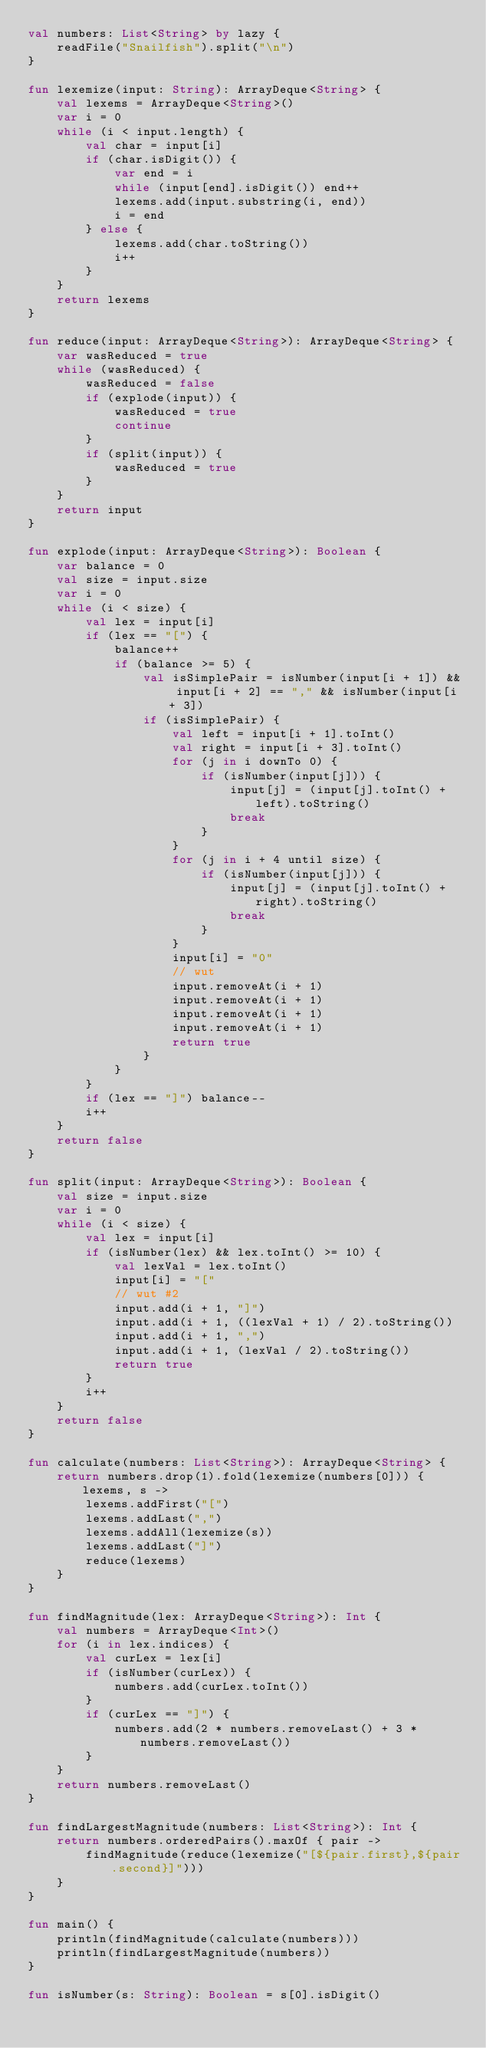Convert code to text. <code><loc_0><loc_0><loc_500><loc_500><_Kotlin_>val numbers: List<String> by lazy {
    readFile("Snailfish").split("\n")
}

fun lexemize(input: String): ArrayDeque<String> {
    val lexems = ArrayDeque<String>()
    var i = 0
    while (i < input.length) {
        val char = input[i]
        if (char.isDigit()) {
            var end = i
            while (input[end].isDigit()) end++
            lexems.add(input.substring(i, end))
            i = end
        } else {
            lexems.add(char.toString())
            i++
        }
    }
    return lexems
}

fun reduce(input: ArrayDeque<String>): ArrayDeque<String> {
    var wasReduced = true
    while (wasReduced) {
        wasReduced = false
        if (explode(input)) {
            wasReduced = true
            continue
        }
        if (split(input)) {
            wasReduced = true
        }
    }
    return input
}

fun explode(input: ArrayDeque<String>): Boolean {
    var balance = 0
    val size = input.size
    var i = 0
    while (i < size) {
        val lex = input[i]
        if (lex == "[") {
            balance++
            if (balance >= 5) {
                val isSimplePair = isNumber(input[i + 1]) && input[i + 2] == "," && isNumber(input[i + 3])
                if (isSimplePair) {
                    val left = input[i + 1].toInt()
                    val right = input[i + 3].toInt()
                    for (j in i downTo 0) {
                        if (isNumber(input[j])) {
                            input[j] = (input[j].toInt() + left).toString()
                            break
                        }
                    }
                    for (j in i + 4 until size) {
                        if (isNumber(input[j])) {
                            input[j] = (input[j].toInt() + right).toString()
                            break
                        }
                    }
                    input[i] = "0"
                    // wut
                    input.removeAt(i + 1)
                    input.removeAt(i + 1)
                    input.removeAt(i + 1)
                    input.removeAt(i + 1)
                    return true
                }
            }
        }
        if (lex == "]") balance--
        i++
    }
    return false
}

fun split(input: ArrayDeque<String>): Boolean {
    val size = input.size
    var i = 0
    while (i < size) {
        val lex = input[i]
        if (isNumber(lex) && lex.toInt() >= 10) {
            val lexVal = lex.toInt()
            input[i] = "["
            // wut #2
            input.add(i + 1, "]")
            input.add(i + 1, ((lexVal + 1) / 2).toString())
            input.add(i + 1, ",")
            input.add(i + 1, (lexVal / 2).toString())
            return true
        }
        i++
    }
    return false
}

fun calculate(numbers: List<String>): ArrayDeque<String> {
    return numbers.drop(1).fold(lexemize(numbers[0])) { lexems, s ->
        lexems.addFirst("[")
        lexems.addLast(",")
        lexems.addAll(lexemize(s))
        lexems.addLast("]")
        reduce(lexems)
    }
}

fun findMagnitude(lex: ArrayDeque<String>): Int {
    val numbers = ArrayDeque<Int>()
    for (i in lex.indices) {
        val curLex = lex[i]
        if (isNumber(curLex)) {
            numbers.add(curLex.toInt())
        }
        if (curLex == "]") {
            numbers.add(2 * numbers.removeLast() + 3 * numbers.removeLast())
        }
    }
    return numbers.removeLast()
}

fun findLargestMagnitude(numbers: List<String>): Int {
    return numbers.orderedPairs().maxOf { pair ->
        findMagnitude(reduce(lexemize("[${pair.first},${pair.second}]")))
    }
}

fun main() {
    println(findMagnitude(calculate(numbers)))
    println(findLargestMagnitude(numbers))
}

fun isNumber(s: String): Boolean = s[0].isDigit()</code> 